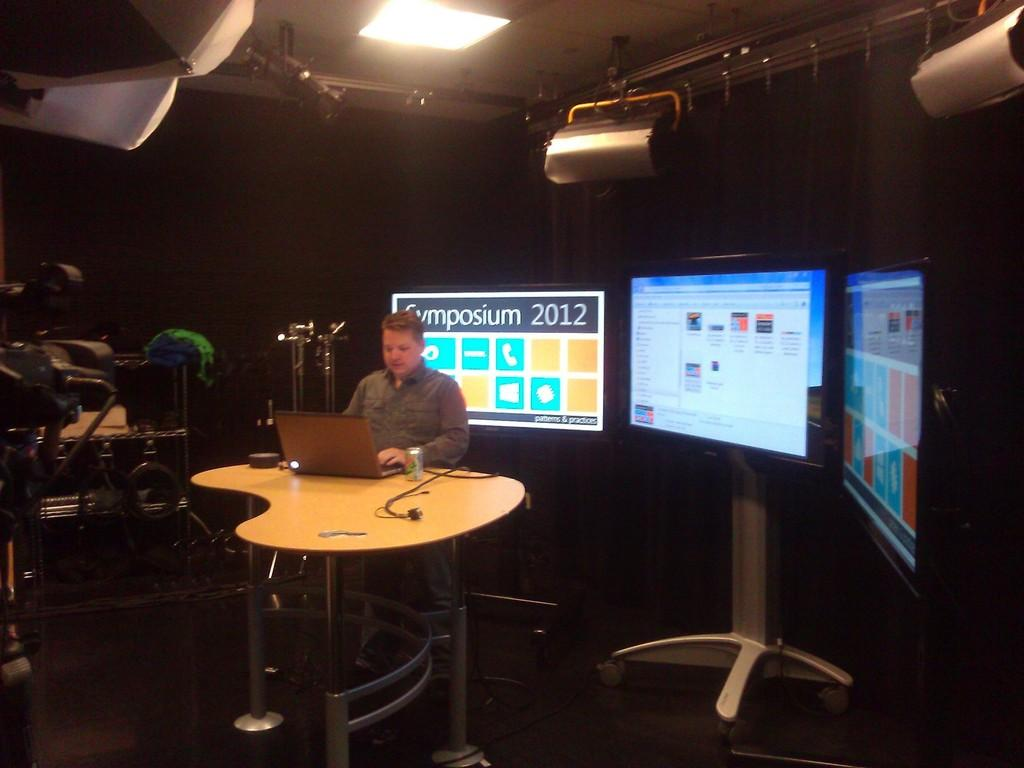Who is the person in the image? There is a man in the image. What is the man doing in the image? The man is sitting in a chair and operating a laptop. Where is the laptop located in the image? The laptop is on a table. What can be seen in the background of the image? There are televisions in the background of the image. How are the televisions positioned in the image? The televisions are fixed to a stand. What type of meal is the man eating in the image? There is no meal present in the image; the man is operating a laptop. How many cars can be seen in the image? There are no cars visible in the image. 